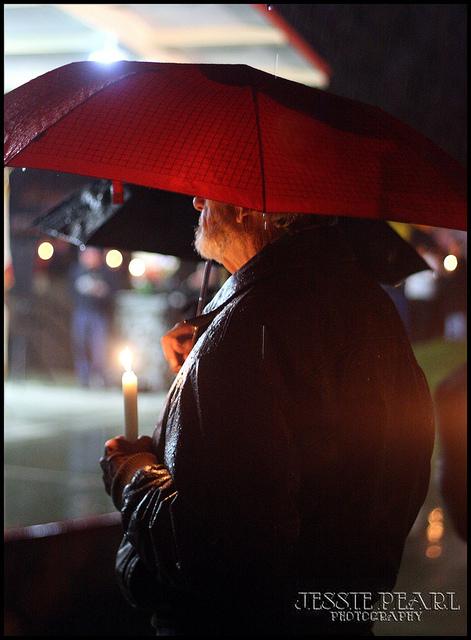Is the person under the umbrella praying with a candle in his hand?
Give a very brief answer. Yes. What color is the large umbrella?
Be succinct. Red. Why is the person holding an umbrella?
Be succinct. Raining. What is the person doing?
Write a very short answer. Holding candle. 